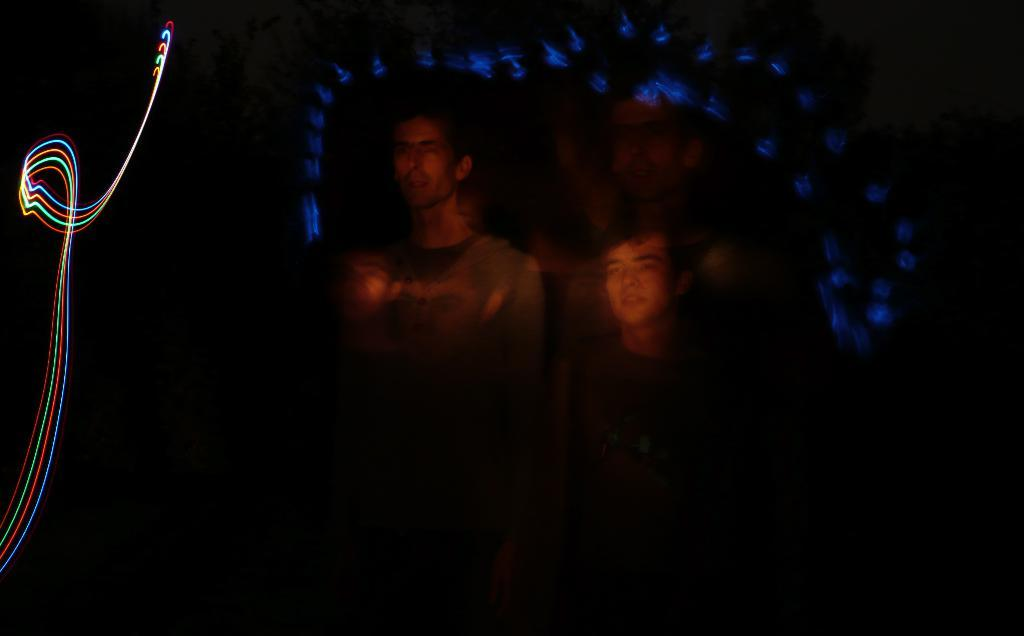How many people are in the image? There are two people in the image. Where are the people located in the image? The people are in the center of the image. What else can be seen in the image besides the people? There are lights visible in the image. What type of hospital equipment can be seen in the image? There is no hospital equipment present in the image. What type of baseball equipment can be seen in the image? There is no baseball equipment present in the image. What type of finger-related object can be seen in the image? There is no finger-related object present in the image. 